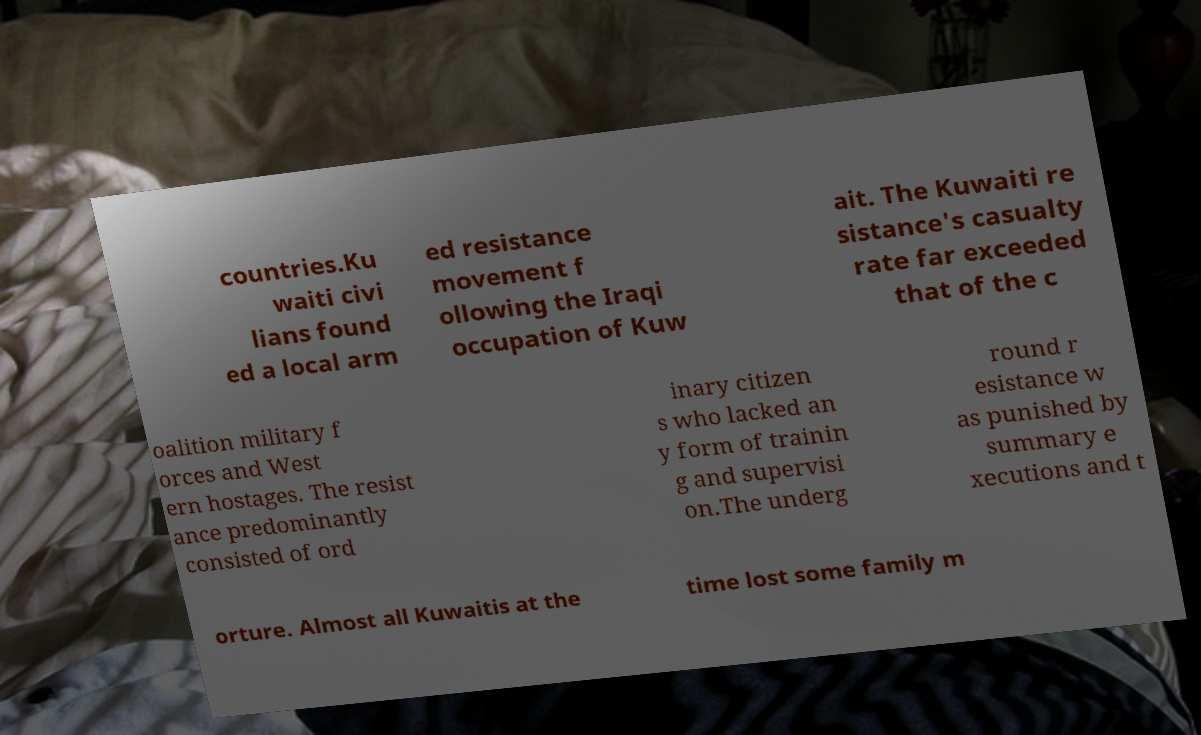Can you read and provide the text displayed in the image?This photo seems to have some interesting text. Can you extract and type it out for me? countries.Ku waiti civi lians found ed a local arm ed resistance movement f ollowing the Iraqi occupation of Kuw ait. The Kuwaiti re sistance's casualty rate far exceeded that of the c oalition military f orces and West ern hostages. The resist ance predominantly consisted of ord inary citizen s who lacked an y form of trainin g and supervisi on.The underg round r esistance w as punished by summary e xecutions and t orture. Almost all Kuwaitis at the time lost some family m 